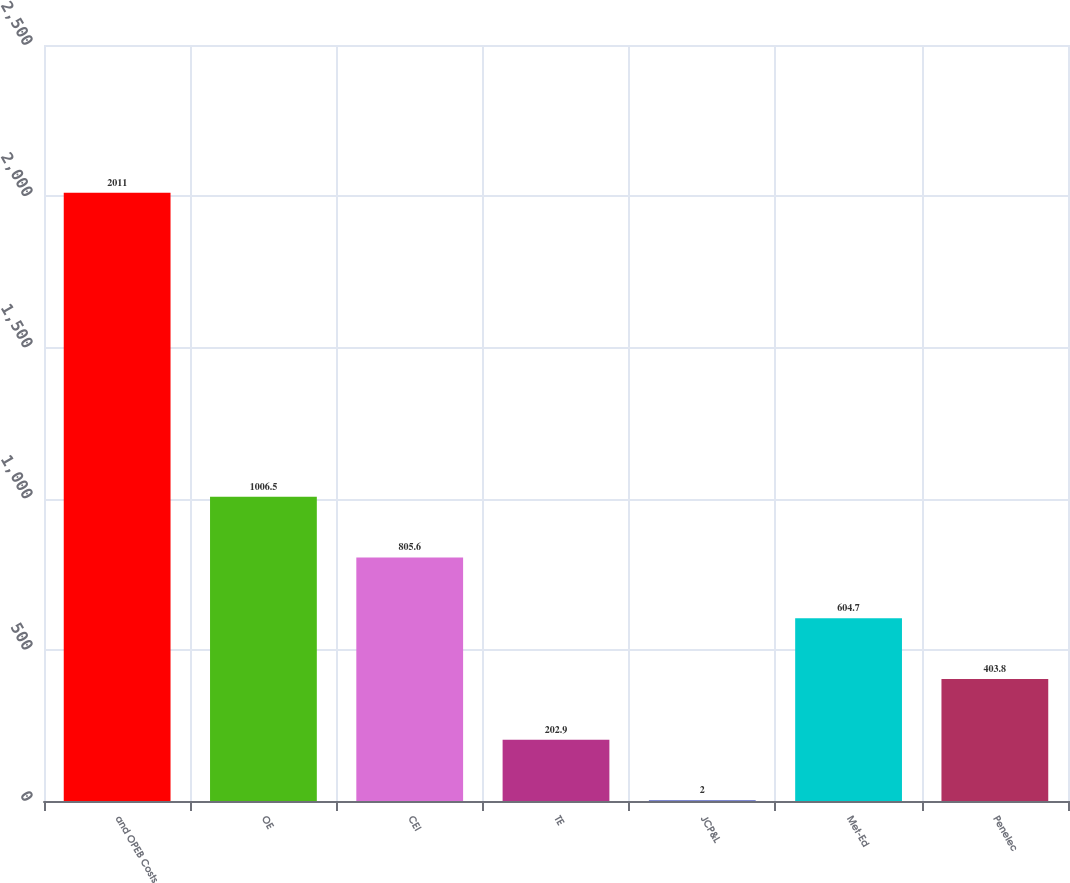Convert chart to OTSL. <chart><loc_0><loc_0><loc_500><loc_500><bar_chart><fcel>and OPEB Costs<fcel>OE<fcel>CEI<fcel>TE<fcel>JCP&L<fcel>Met-Ed<fcel>Penelec<nl><fcel>2011<fcel>1006.5<fcel>805.6<fcel>202.9<fcel>2<fcel>604.7<fcel>403.8<nl></chart> 